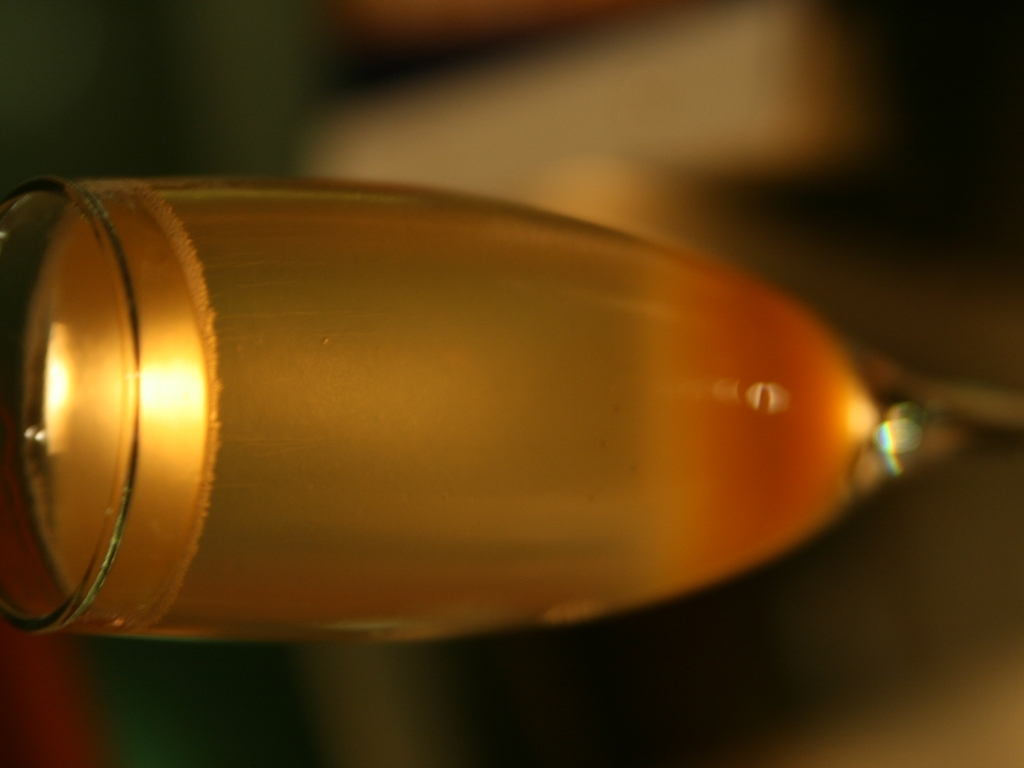What might be the content of this tilted image? It appears to be an image of a glass containing a liquid, possibly a beverage. Due to the angle, we're seeing the liquid at the brink of spilling, creating a sense of tension and the anticipation of movement. Could the tilt of the image have artistic implications? Absolutely, the unique tilt can be an artistic choice to evoke certain emotions or to encourage viewers to see an everyday object like a glass of beverage from a new perspective, possibly challenging their perceptions of balance and stability. 